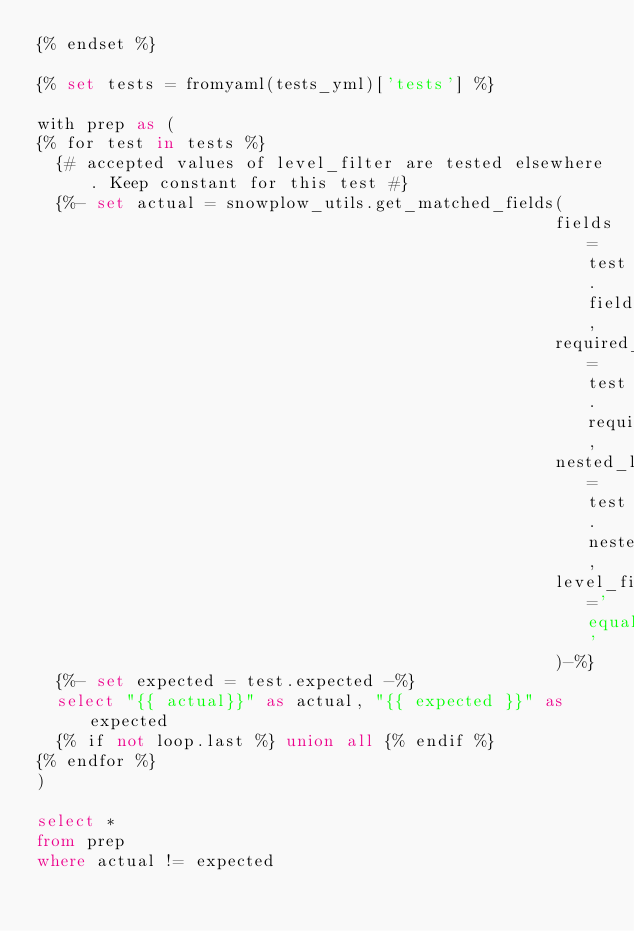Convert code to text. <code><loc_0><loc_0><loc_500><loc_500><_SQL_>{% endset %}

{% set tests = fromyaml(tests_yml)['tests'] %}

with prep as (
{% for test in tests %}
  {# accepted values of level_filter are tested elsewhere. Keep constant for this test #}
  {%- set actual = snowplow_utils.get_matched_fields(
                                                    fields=test.fields,
                                                    required_field_names=test.required_field_names,
                                                    nested_level=test.nested_level,
                                                    level_filter='equalto'
                                                    )-%}
  {%- set expected = test.expected -%}
  select "{{ actual}}" as actual, "{{ expected }}" as expected
  {% if not loop.last %} union all {% endif %}
{% endfor %}
)

select * 
from prep
where actual != expected
</code> 